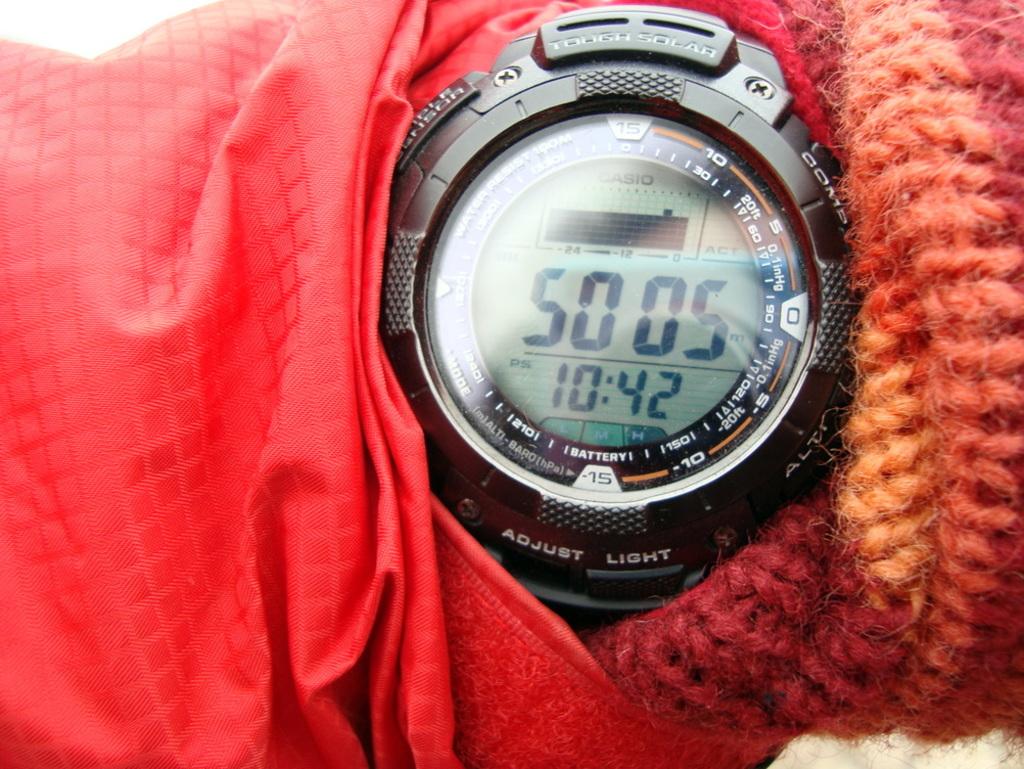What is the time?
Provide a succinct answer. 10:42. What brand is the watch?
Keep it short and to the point. Casio. 